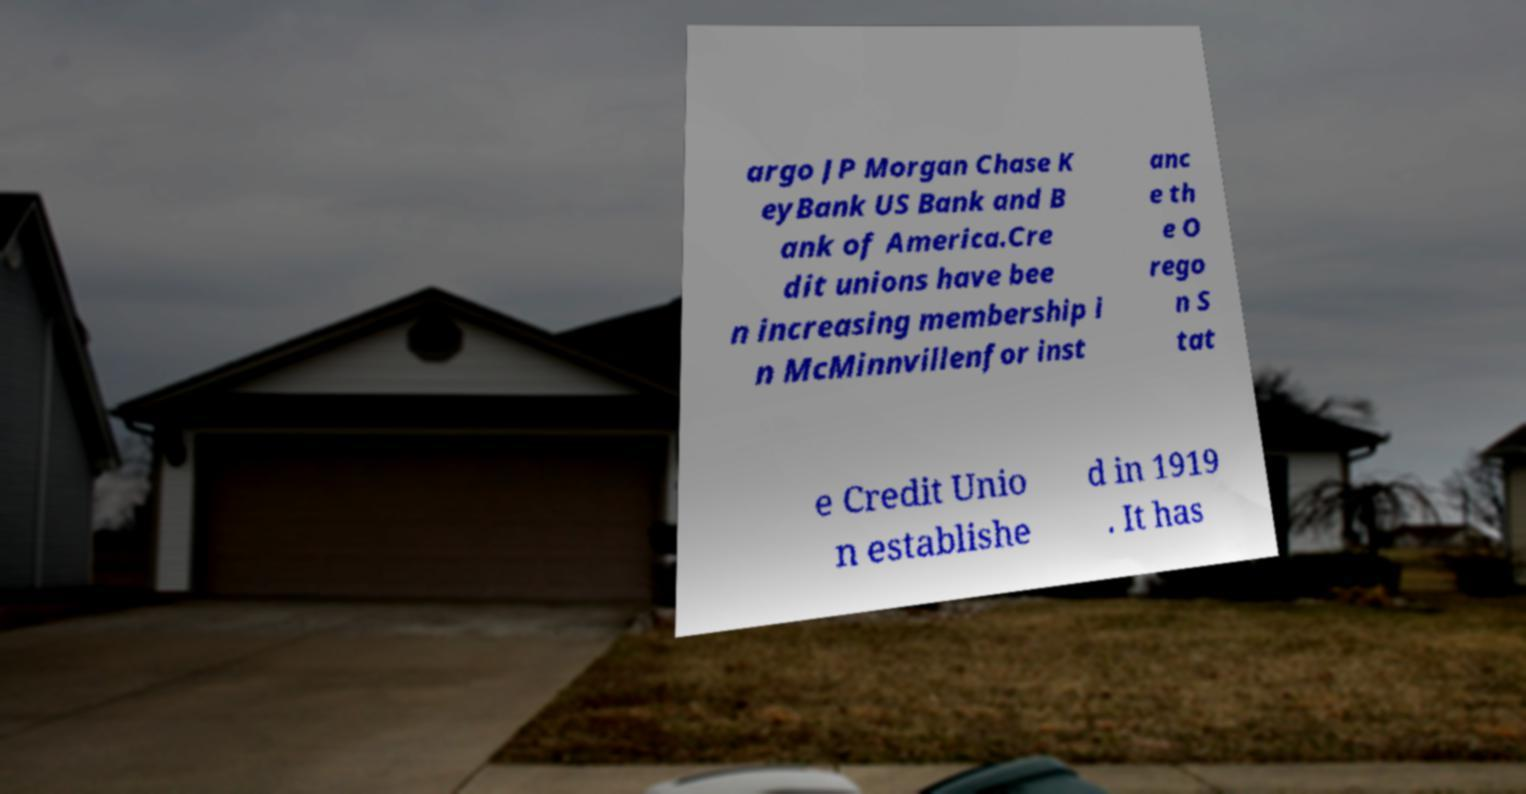Please read and relay the text visible in this image. What does it say? argo JP Morgan Chase K eyBank US Bank and B ank of America.Cre dit unions have bee n increasing membership i n McMinnvillenfor inst anc e th e O rego n S tat e Credit Unio n establishe d in 1919 . It has 